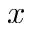Convert formula to latex. <formula><loc_0><loc_0><loc_500><loc_500>x</formula> 